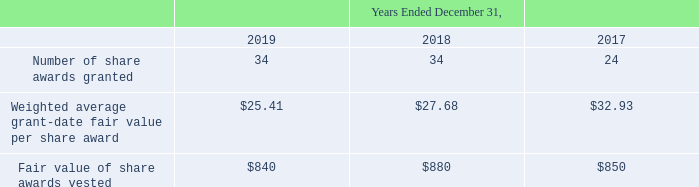The following table summarizes information regarding common stock share awards granted and vested (in thousands, except per share award amounts):
As of December 31, 2019, there was $0.2 million of total unrecognized compensation costs, net of actual forfeitures, related to nonvested common stock share awards. This cost is expected to be recognized over a weighted average period of 0.8 years.
What was the Number of share awards granted in 2019?
Answer scale should be: thousand. 34. What was the Fair value of share awards vested in 2017?
Answer scale should be: thousand. $850. In which years was the Number of share awards granted calculated? 2019, 2018, 2017. In which year was the Weighted average grant-date fair value per share award the largest? $32.93>$27.68>$25.41
Answer: 2017. What was the change in Fair value of share awards vested in 2019 from 2018?
Answer scale should be: thousand. 840-880
Answer: -40. What was the percentage change in Fair value of share awards vested in 2019 from 2018?
Answer scale should be: percent. (840-880)/880
Answer: -4.55. 